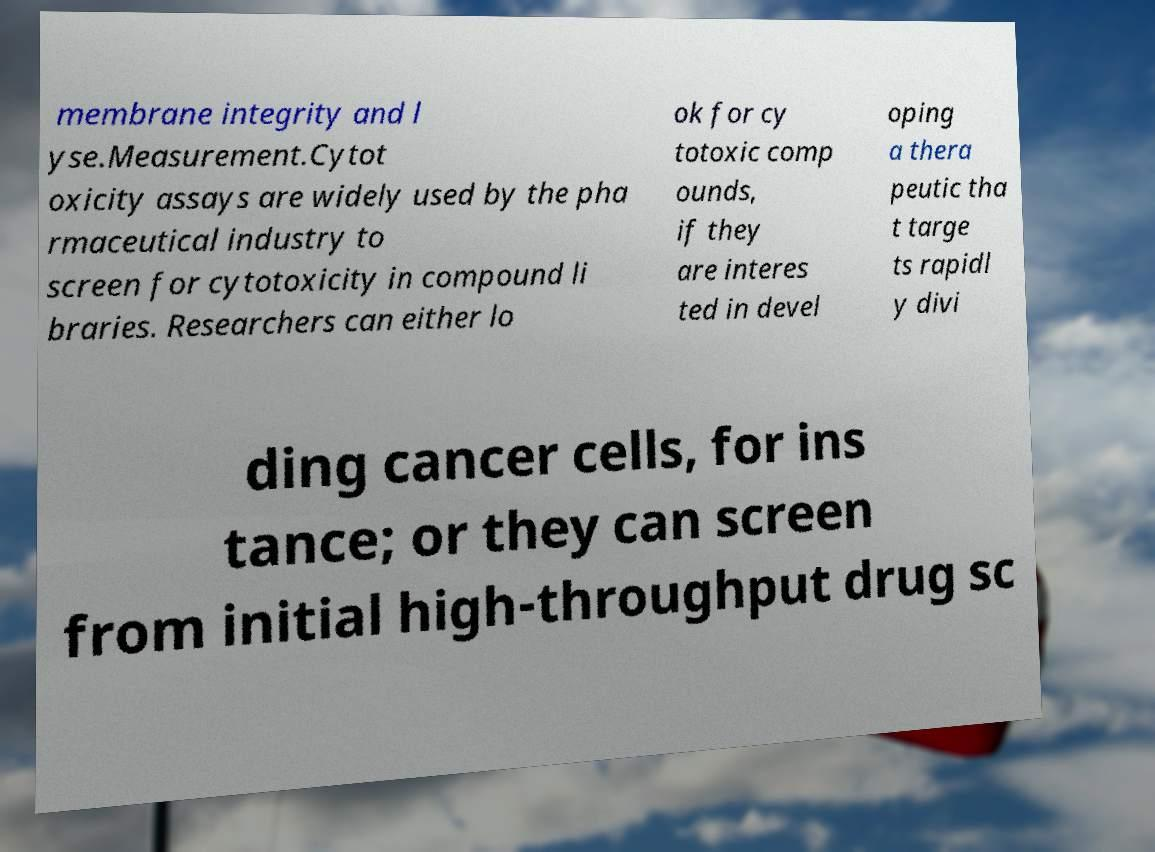Please read and relay the text visible in this image. What does it say? membrane integrity and l yse.Measurement.Cytot oxicity assays are widely used by the pha rmaceutical industry to screen for cytotoxicity in compound li braries. Researchers can either lo ok for cy totoxic comp ounds, if they are interes ted in devel oping a thera peutic tha t targe ts rapidl y divi ding cancer cells, for ins tance; or they can screen from initial high-throughput drug sc 